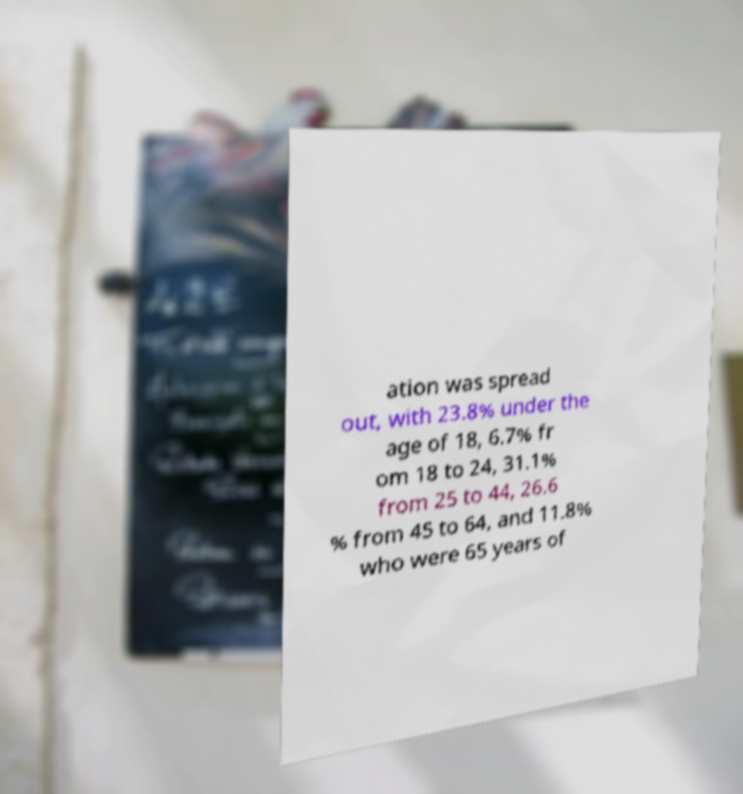Can you read and provide the text displayed in the image?This photo seems to have some interesting text. Can you extract and type it out for me? ation was spread out, with 23.8% under the age of 18, 6.7% fr om 18 to 24, 31.1% from 25 to 44, 26.6 % from 45 to 64, and 11.8% who were 65 years of 